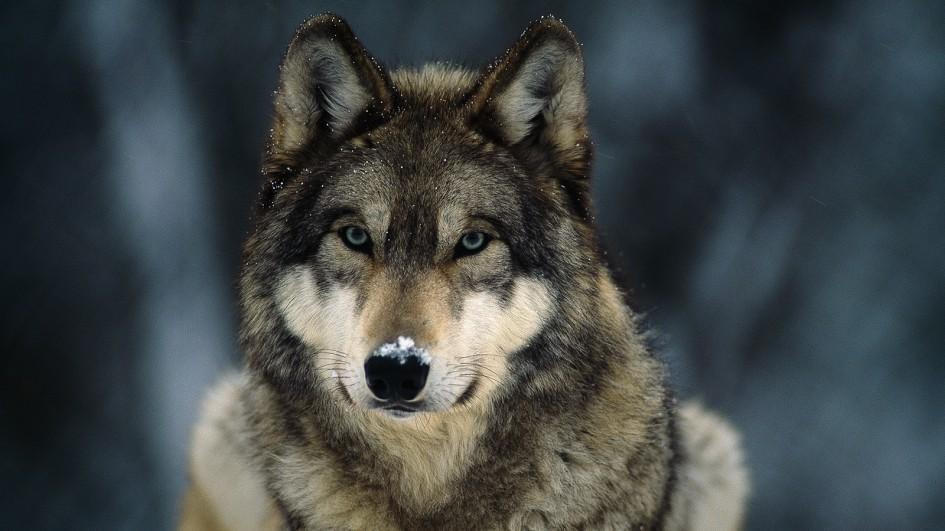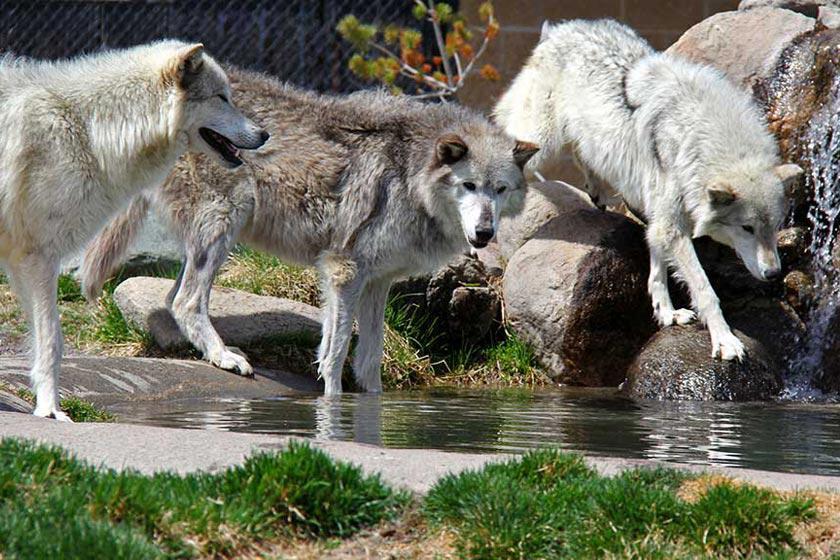The first image is the image on the left, the second image is the image on the right. Given the left and right images, does the statement "At least one dog has its front paws standing in a pool of water surrounded by rocks and green grass." hold true? Answer yes or no. Yes. 